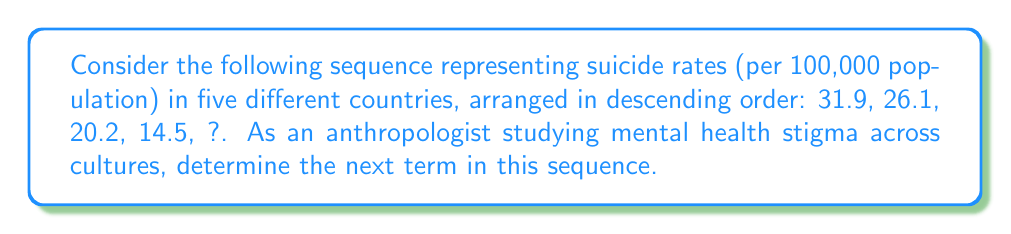Help me with this question. To solve this problem, we need to identify the pattern in the given sequence:

1. Calculate the differences between consecutive terms:
   31.9 - 26.1 = 5.8
   26.1 - 20.2 = 5.9
   20.2 - 14.5 = 5.7

2. Observe that the differences are approximately constant, with a mean of:
   $\frac{5.8 + 5.9 + 5.7}{3} = 5.8$

3. This suggests an arithmetic sequence with a common difference of about -5.8.

4. To find the next term, subtract 5.8 from the last given term:
   14.5 - 5.8 = 8.7

5. Round to one decimal place for consistency with the given data:
   8.7 ≈ 8.7 (no rounding needed)

As an anthropologist, this declining sequence could represent countries with varying levels of mental health awareness and support systems, potentially correlating with cultural attitudes towards mental health and suicide prevention.
Answer: 8.7 